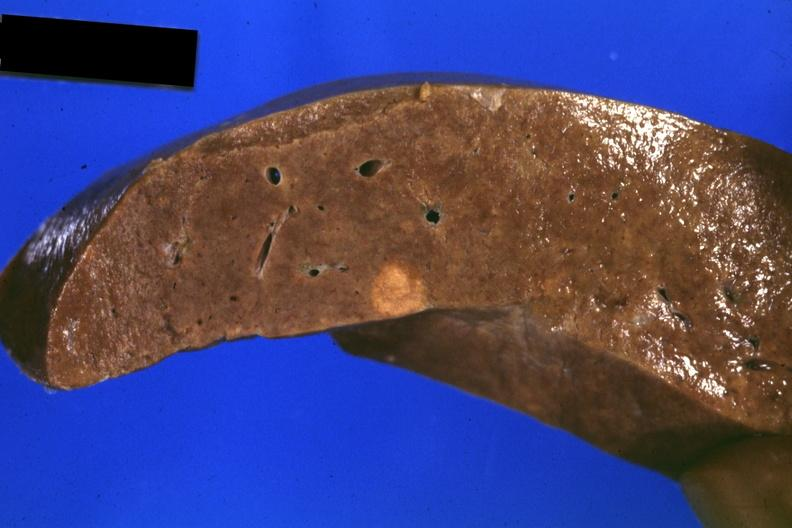does this image show fixed tissue close-up of tumor mass in liver?
Answer the question using a single word or phrase. Yes 